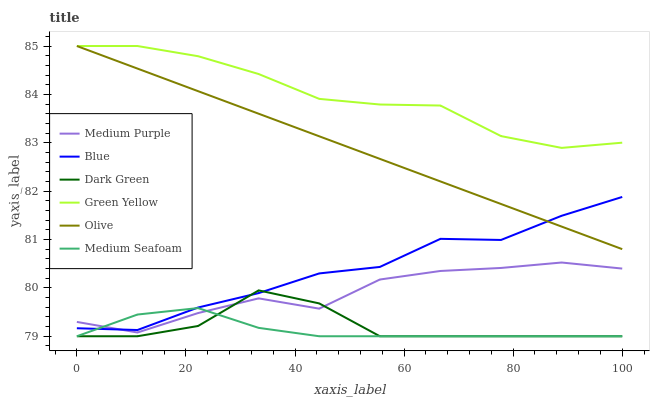Does Medium Seafoam have the minimum area under the curve?
Answer yes or no. Yes. Does Green Yellow have the maximum area under the curve?
Answer yes or no. Yes. Does Medium Purple have the minimum area under the curve?
Answer yes or no. No. Does Medium Purple have the maximum area under the curve?
Answer yes or no. No. Is Olive the smoothest?
Answer yes or no. Yes. Is Medium Purple the roughest?
Answer yes or no. Yes. Is Medium Purple the smoothest?
Answer yes or no. No. Is Olive the roughest?
Answer yes or no. No. Does Medium Seafoam have the lowest value?
Answer yes or no. Yes. Does Medium Purple have the lowest value?
Answer yes or no. No. Does Green Yellow have the highest value?
Answer yes or no. Yes. Does Medium Purple have the highest value?
Answer yes or no. No. Is Dark Green less than Green Yellow?
Answer yes or no. Yes. Is Green Yellow greater than Medium Seafoam?
Answer yes or no. Yes. Does Green Yellow intersect Olive?
Answer yes or no. Yes. Is Green Yellow less than Olive?
Answer yes or no. No. Is Green Yellow greater than Olive?
Answer yes or no. No. Does Dark Green intersect Green Yellow?
Answer yes or no. No. 